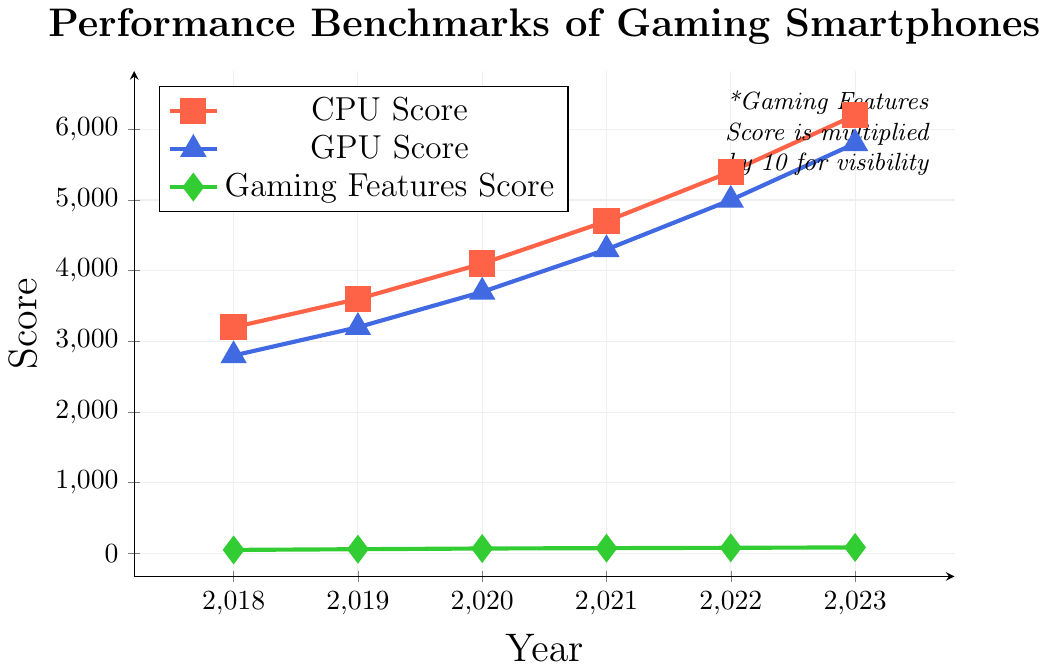What year shows the highest CPU score? To find the highest CPU score, we look at the y-axis values for the CPU plot (red squares) and identify the year corresponding to the maximum score. The highest value is 6200 in the year 2023.
Answer: 2023 How does the GPU score change from 2018 to 2023? Identify the GPU scores (blue triangles) for 2018 and 2023, which are 2800 and 5800, respectively. The change can be calculated as 5800 - 2800.
Answer: 3000 Which year shows the smallest increase in Gaming Features Score compared to the previous year? Examine the green diamonds representing Gaming Features Scores, calculating yearly differences: 
2019: 60 - 50 = 10,
2020: 70 - 60 = 10,
2021: 75 - 70 = 5,
2022: 80 - 75 = 5,
2023: 85 - 80 = 5,
The smallest increase is 5 (years 2021, 2022, and 2023).
Answer: 2021, 2022, 2023 Which score shows the most significant overall increase from 2018 to 2023? Determine the difference for each score type from 2018 to 2023:
CPU: 6200 - 3200 = 3000,
GPU: 5800 - 2800 = 3000,
Gaming Features: 85 - 50 = 35,
The most significant increase is for CPU and GPU, both 3000.
Answer: CPU, GPU What is the average GPU score over the entire period? Calculate the sum of GPU scores (2800 + 3200 + 3700 + 4300 + 5000 + 5800) = 24800 and divide it by the number of years (6).
Answer: 4133.33 Compare the trends of CPU and GPU scores from 2018 to 2023. Which trend is steeper? Look at the slopes of the lines representing CPU (red squares) and GPU (blue triangles). Both increase linearly, but CPU scores go from 3200 to 6200 (slope = 3000); GPU scores go from 2800 to 5800 (slope = 3000). Since the slopes are equal, neither trend is steeper.
Answer: Both are equal Between which two consecutive years is the most significant increase in the GPU score observed? Calculate the year-over-year differences for GPU scores:
2019: 3200 - 2800 = 400,
2020: 3700 - 3200 = 500,
2021: 4300 - 3700 = 600,
2022: 5000 - 4300 = 700,
2023: 5800 - 5000 = 800,
The most considerable increase is between 2022 and 2023.
Answer: 2022 and 2023 